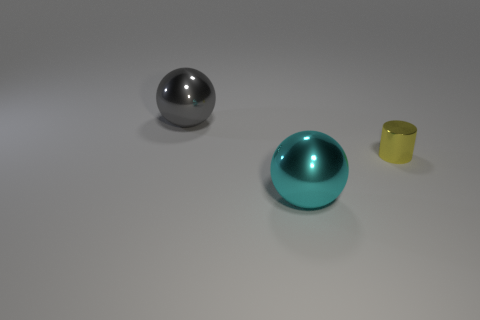There is a small yellow metallic object; is it the same shape as the big object that is behind the yellow object?
Provide a short and direct response. No. There is a ball on the right side of the large shiny thing that is behind the metal sphere that is right of the big gray shiny sphere; what color is it?
Give a very brief answer. Cyan. There is a tiny yellow shiny cylinder; are there any cyan metallic things behind it?
Offer a very short reply. No. Are there any cyan spheres that have the same material as the cyan object?
Provide a succinct answer. No. What color is the cylinder?
Your answer should be very brief. Yellow. Is the shape of the big metallic object that is in front of the yellow shiny cylinder the same as  the tiny thing?
Ensure brevity in your answer.  No. There is a shiny object that is to the left of the metal sphere in front of the thing that is left of the cyan sphere; what shape is it?
Your answer should be compact. Sphere. There is a big object that is to the right of the gray shiny sphere; what is its material?
Give a very brief answer. Metal. What color is the other object that is the same size as the gray object?
Your answer should be very brief. Cyan. How many other objects are the same shape as the gray metallic thing?
Offer a terse response. 1. 